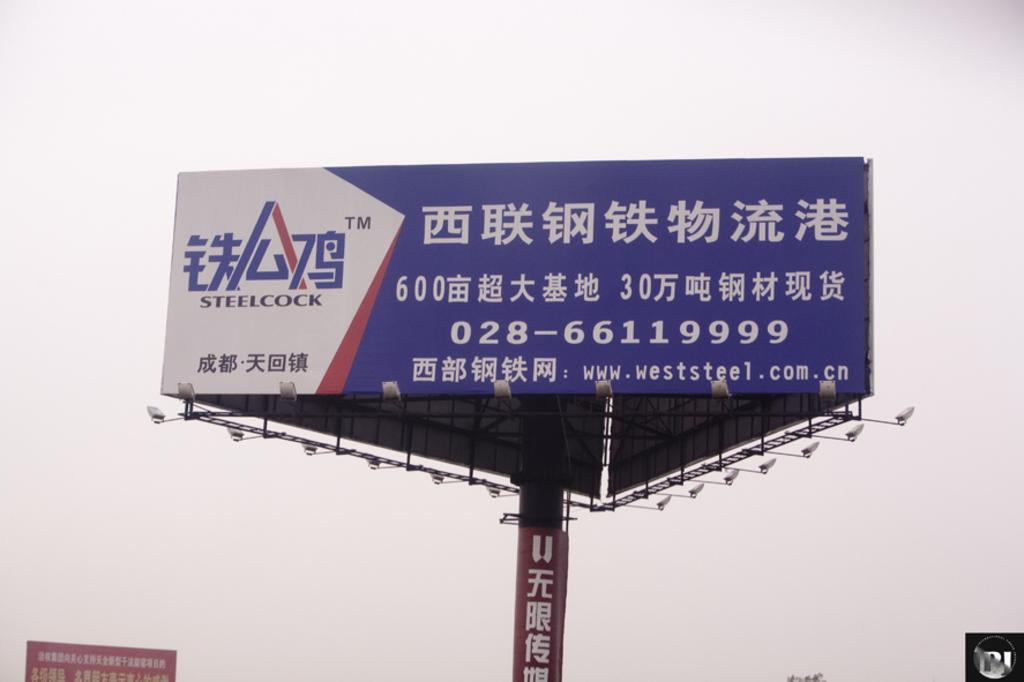Provide a one-sentence caption for the provided image. a large blue and white billboard featuring steelcock written in mandarin. 